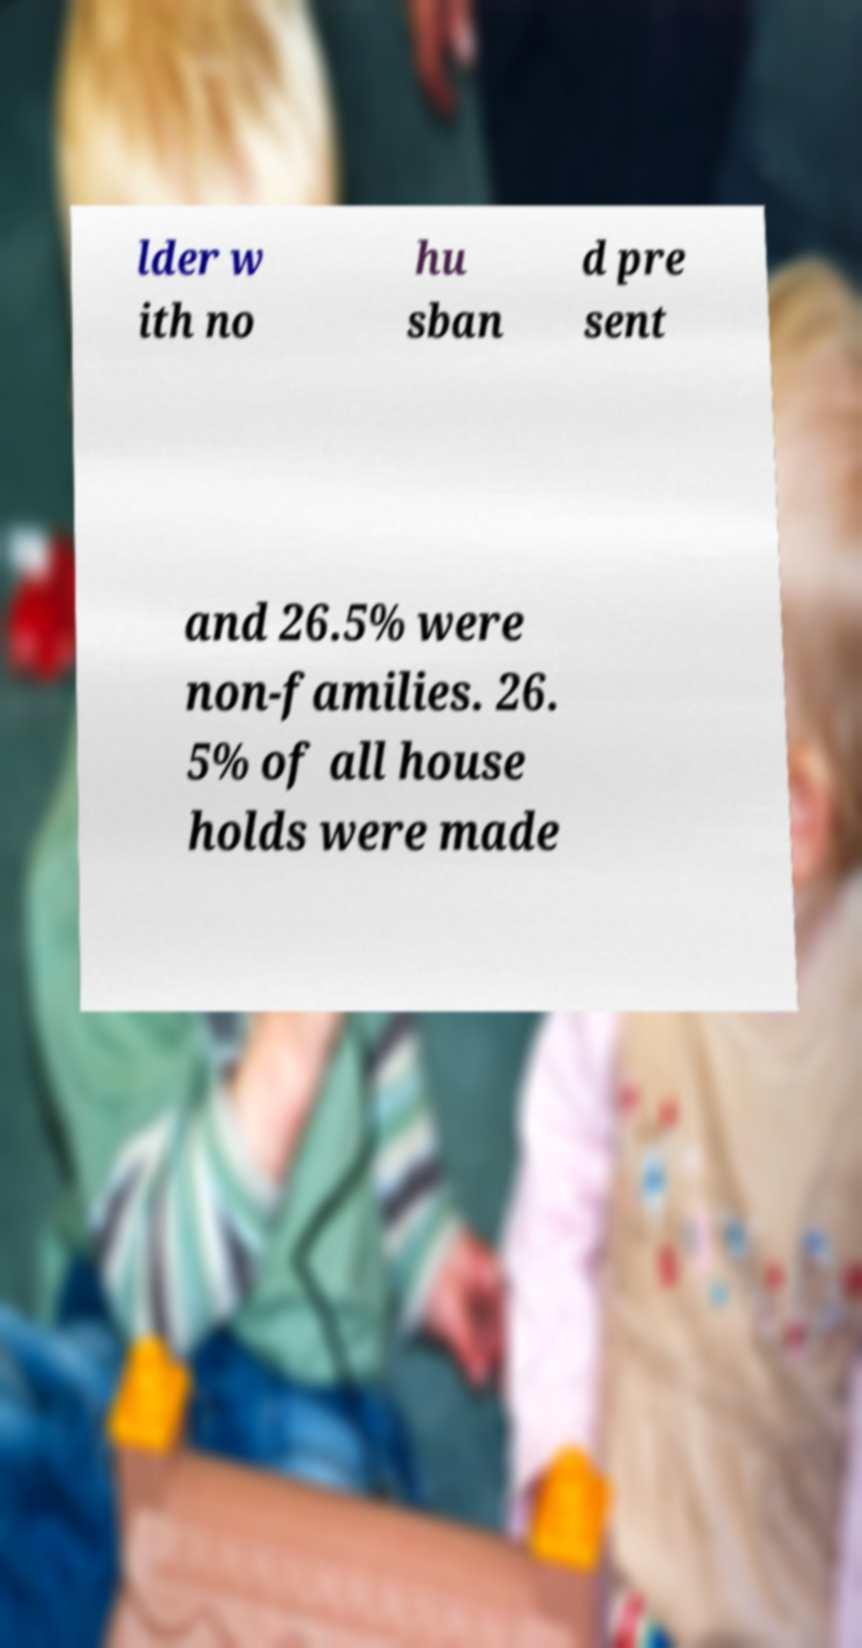There's text embedded in this image that I need extracted. Can you transcribe it verbatim? lder w ith no hu sban d pre sent and 26.5% were non-families. 26. 5% of all house holds were made 